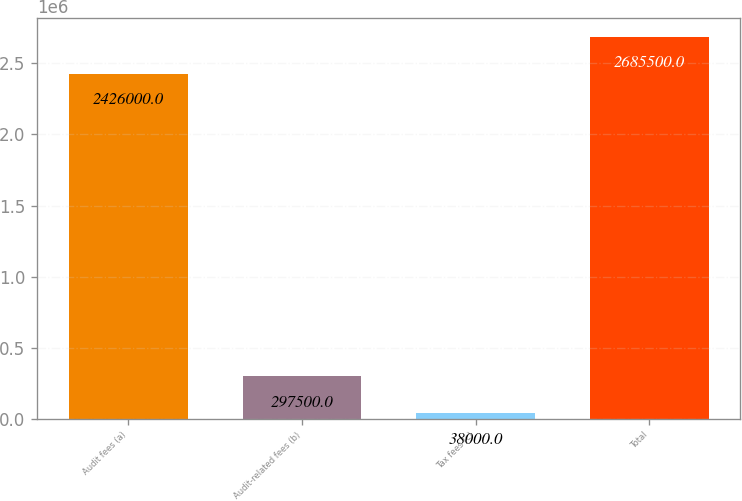<chart> <loc_0><loc_0><loc_500><loc_500><bar_chart><fcel>Audit fees (a)<fcel>Audit-related fees (b)<fcel>Tax fees (c)<fcel>Total<nl><fcel>2.426e+06<fcel>297500<fcel>38000<fcel>2.6855e+06<nl></chart> 